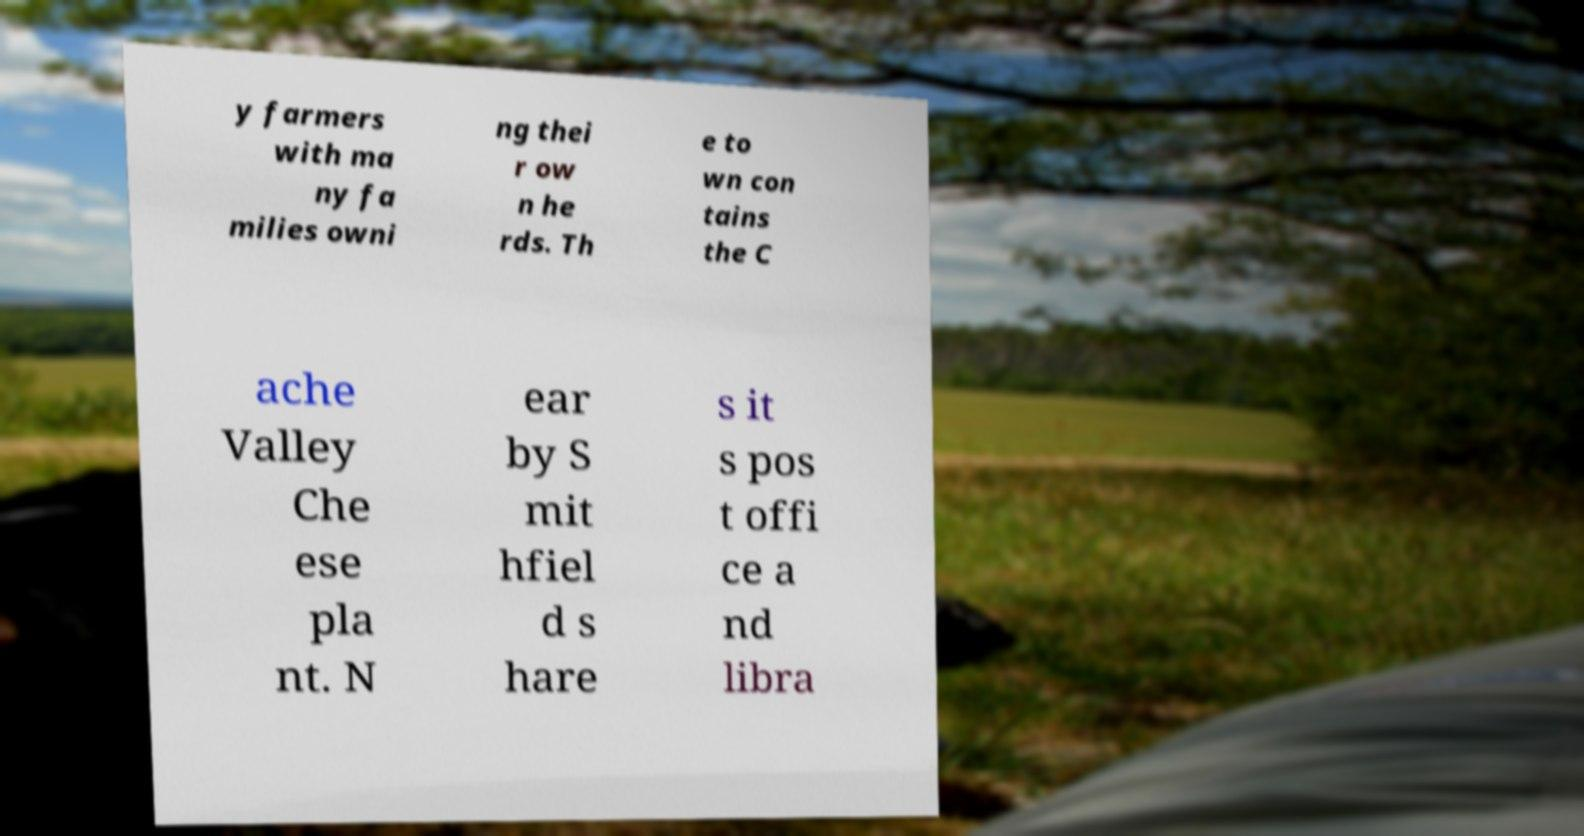Could you assist in decoding the text presented in this image and type it out clearly? y farmers with ma ny fa milies owni ng thei r ow n he rds. Th e to wn con tains the C ache Valley Che ese pla nt. N ear by S mit hfiel d s hare s it s pos t offi ce a nd libra 